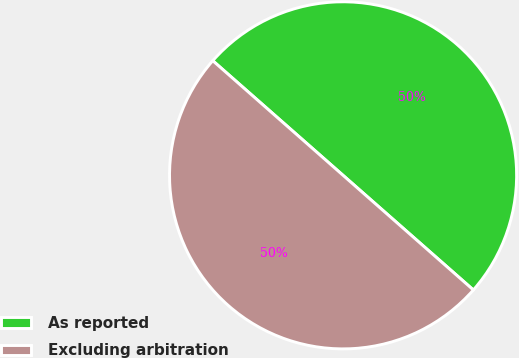<chart> <loc_0><loc_0><loc_500><loc_500><pie_chart><fcel>As reported<fcel>Excluding arbitration<nl><fcel>50.0%<fcel>50.0%<nl></chart> 